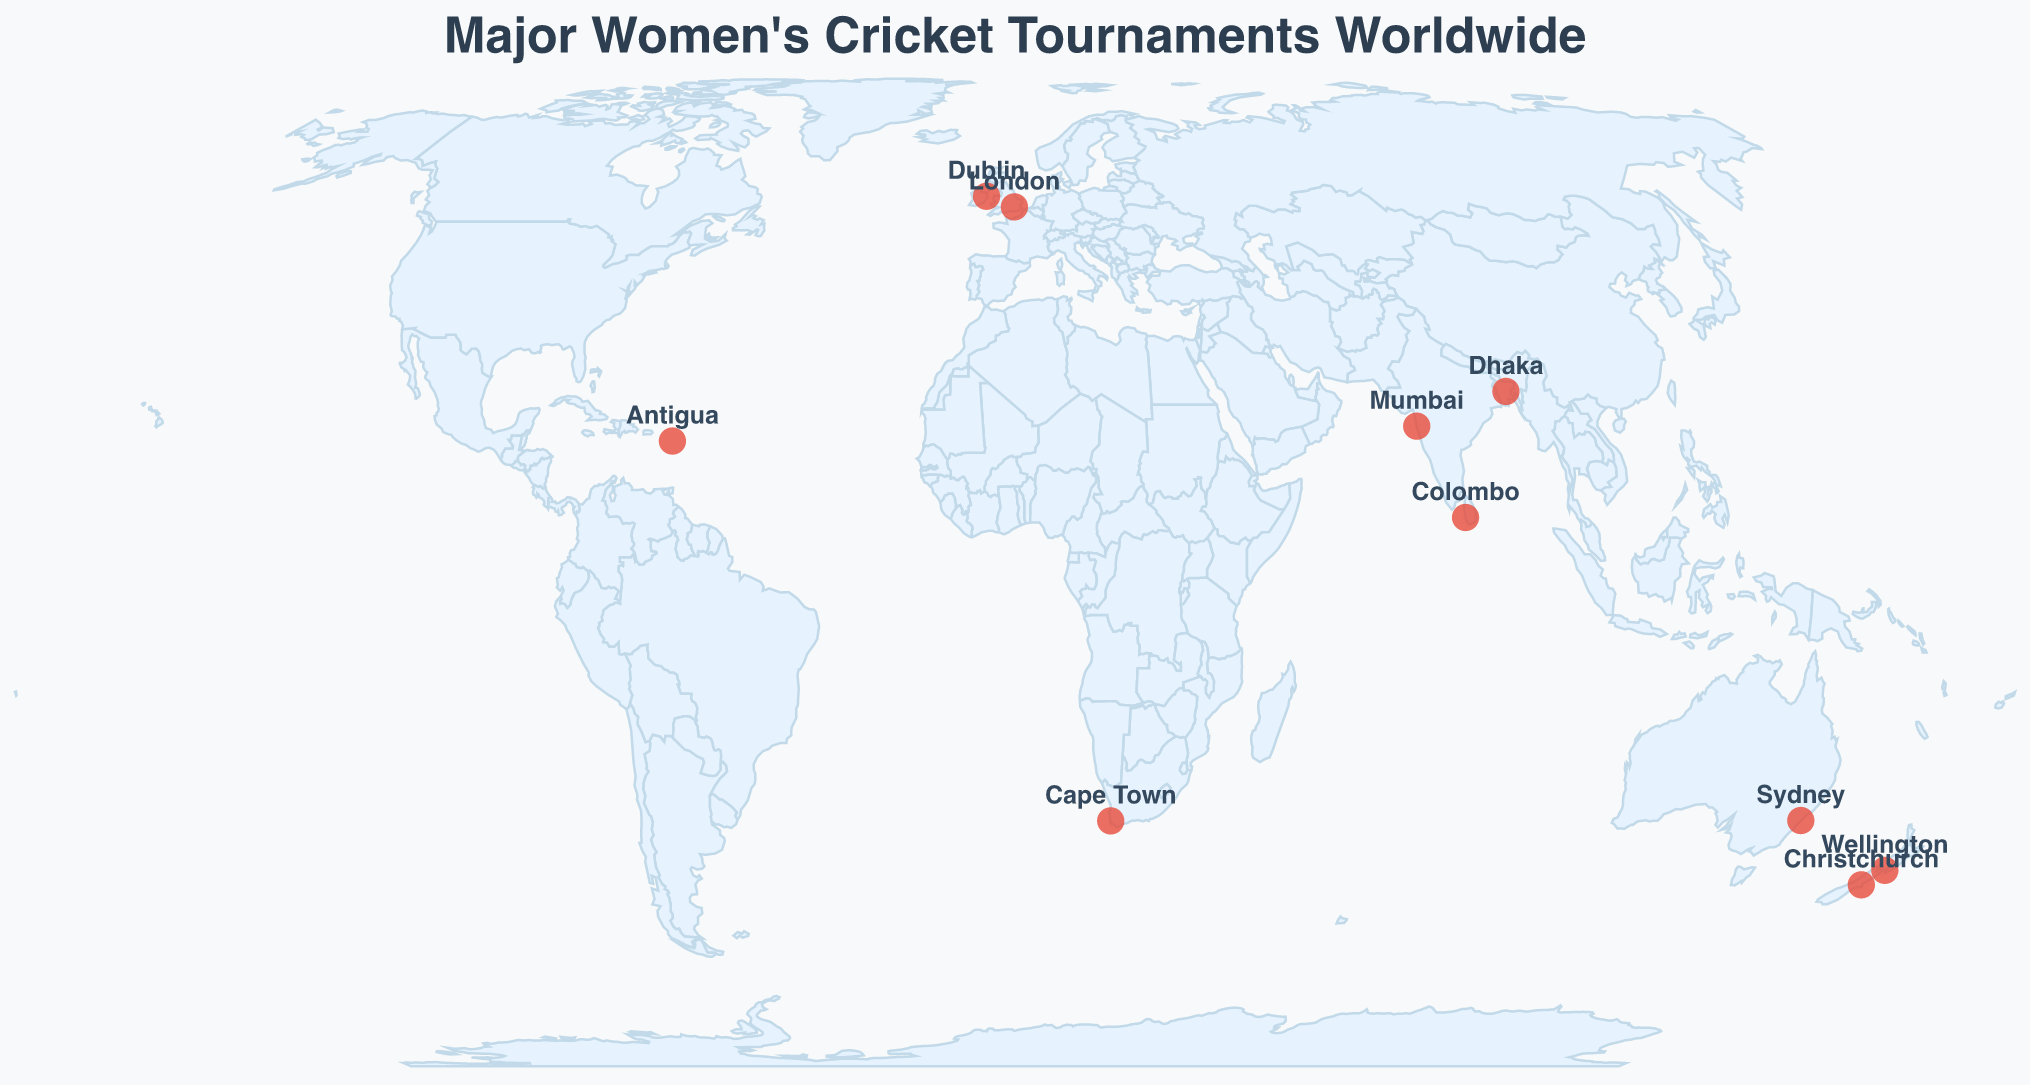What is the title of this figure? The title of the figure is located at the top and is written in large font size.
Answer: Major Women's Cricket Tournaments Worldwide How many major women's cricket tournaments are marked on the map? By counting all the circles on the map, which represent the locations of the tournaments, we see there are 10 in total.
Answer: 10 Which location is hosting the Women's Championship? By hovering over each point and looking at the tooltip that appears, Wellington shows it is hosting the Women's Championship.
Answer: Wellington What tournament is held in Mumbai? By finding the circle at the coordinates for Mumbai (19.0760, 72.8777) and checking the tooltip, we can see it hosts the Women's Premier League.
Answer: Women's Premier League Between Cape Town and Sydney, which one is located further south? By comparing the latitude values of Cape Town (-33.9249) and Sydney (-33.8688), the smaller (more negative) value indicates Cape Town is further south.
Answer: Cape Town In which city is the ICC Women's World Twenty20 held? By hovering over the points and checking the tooltip for each one, the tournament is shown to be held in Antigua.
Answer: Antigua Are there any tournaments held near the equator? By analyzing the latitude of each location, Colombo (6.9271) and Dhaka (23.8103) are located relatively close to the equator. Colombo is closer.
Answer: Colombo (6.9271) Which tournament is hosted in the city with the highest latitude? By looking at the latitude values, Dublin has the highest latitude value (53.3498). Hovering over it reveals it hosts the ICC Women's T20 World Cup Qualifier.
Answer: ICC Women's T20 World Cup Qualifier How many tournaments are held in cities located in the Southern Hemisphere? By identifying cities with negative latitude values, we find Sydney, Christchurch, Cape Town, and Wellington in the Southern Hemisphere. That's 4 cities.
Answer: 4 Is the Women's Ashes Series hosted in a city located east or west of London? By comparing the longitude values, Sydney (151.2093) is located east of London (-0.1278).
Answer: East 